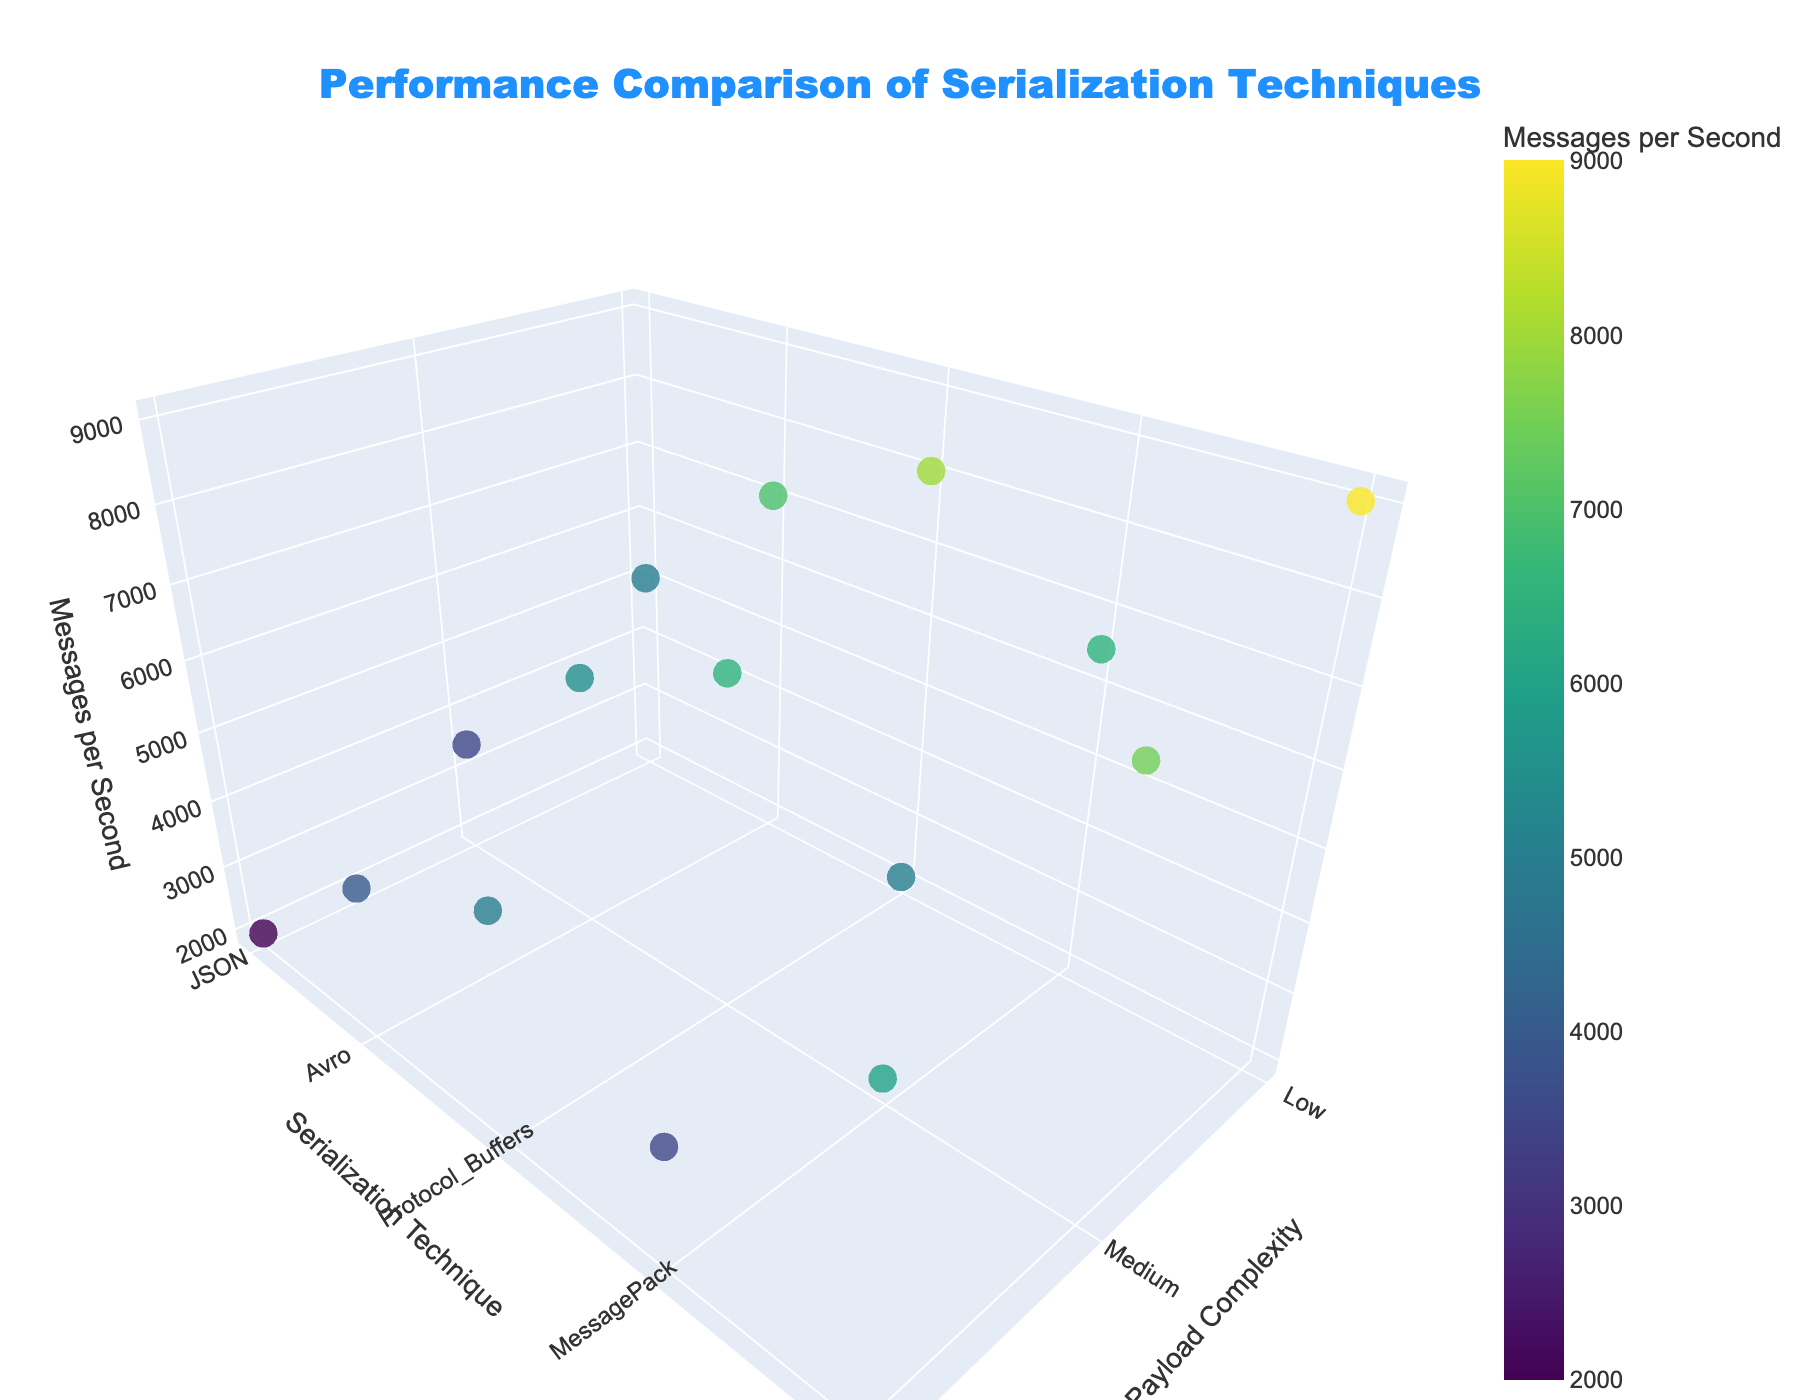What is the title of the figure? The title can be found at the top of the figure. It reads "Performance Comparison of Serialization Techniques."
Answer: Performance Comparison of Serialization Techniques Which serialization technique has the highest number of messages per second for medium payload complexity? By observing the 'Medium' tick on the Payload Complexity axis and checking the marker positions, we find that Kryo has the highest value of 7500 messages per second.
Answer: Kryo How many serialization techniques are displayed in the plot? The Y-axis of the figure labels the different serialization techniques. Counting these labels, we find there are five: JSON, Avro, Protocol_Buffers, MessagePack, and Kryo.
Answer: Five Compare the performance of Avro and JSON for high payload complexity. Which one performs better, and by how much? For high payload complexity, Avro handles 4000 messages per second, whereas JSON handles 2000 messages per second. Therefore, Avro is better by 4000 - 2000 = 2000 messages per second.
Answer: Avro, by 2000 messages per second What are the axis titles of the plot? The titles for the axes are displayed along the respective dimensions of the plot. X-axis is 'Payload Complexity,' Y-axis is 'Serialization Technique,' and Z-axis is 'Messages per Second.'
Answer: Payload Complexity, Serialization Technique, Messages per Second Which serialization technique shows the steepest decline in performance as payload complexity increases from low to high? By comparing the drop in 'Messages per Second' for each serialization technique from 'Low' to 'High' payload complexity, JSON shows the steepest decline from 5000 to 2000 messages per second, a difference of 3000.
Answer: JSON Examine the trend for Protocol_Buffers and provide its performance for all three levels of payload complexity. By observing Protocol_Buffers' markers, for Low payload complexity it supports 8000 messages per second, for Medium it supports 6500 messages per second, and for High it supports 5000 messages per second.
Answer: 8000 (Low), 6500 (Medium), 5000 (High) Which serialization technique has the best performance overall across all payload complexities? This can be determined by looking at each serialization technique's data points: Kryo consistently shows the highest performance across all payload complexities.
Answer: Kryo 